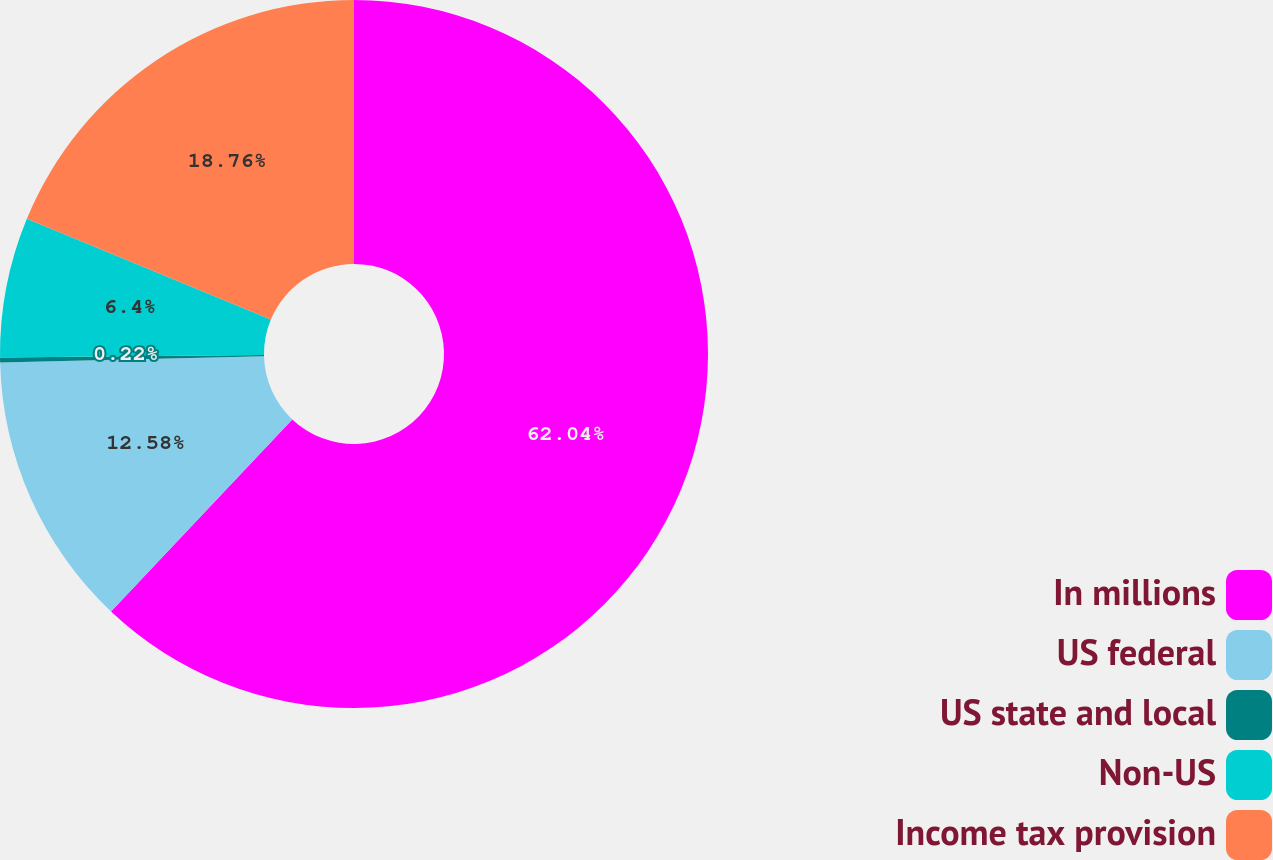Convert chart to OTSL. <chart><loc_0><loc_0><loc_500><loc_500><pie_chart><fcel>In millions<fcel>US federal<fcel>US state and local<fcel>Non-US<fcel>Income tax provision<nl><fcel>62.04%<fcel>12.58%<fcel>0.22%<fcel>6.4%<fcel>18.76%<nl></chart> 